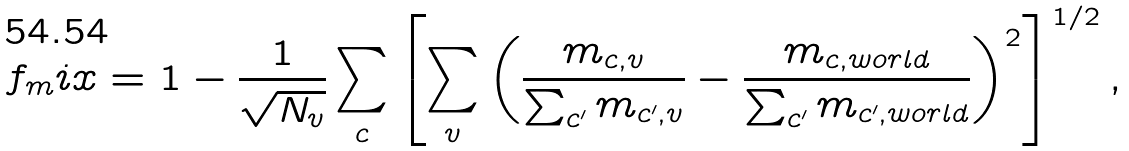Convert formula to latex. <formula><loc_0><loc_0><loc_500><loc_500>f _ { m } i x = 1 - \frac { 1 } { \sqrt { N _ { v } } } \sum _ { c } \left [ \sum _ { v } \left ( \frac { m _ { c , v } } { \sum _ { c ^ { \prime } } m _ { c ^ { \prime } , v } } - \frac { m _ { c , w o r l d } } { \sum _ { c ^ { \prime } } m _ { c ^ { \prime } , w o r l d } } \right ) ^ { 2 } \right ] ^ { 1 / 2 } ,</formula> 